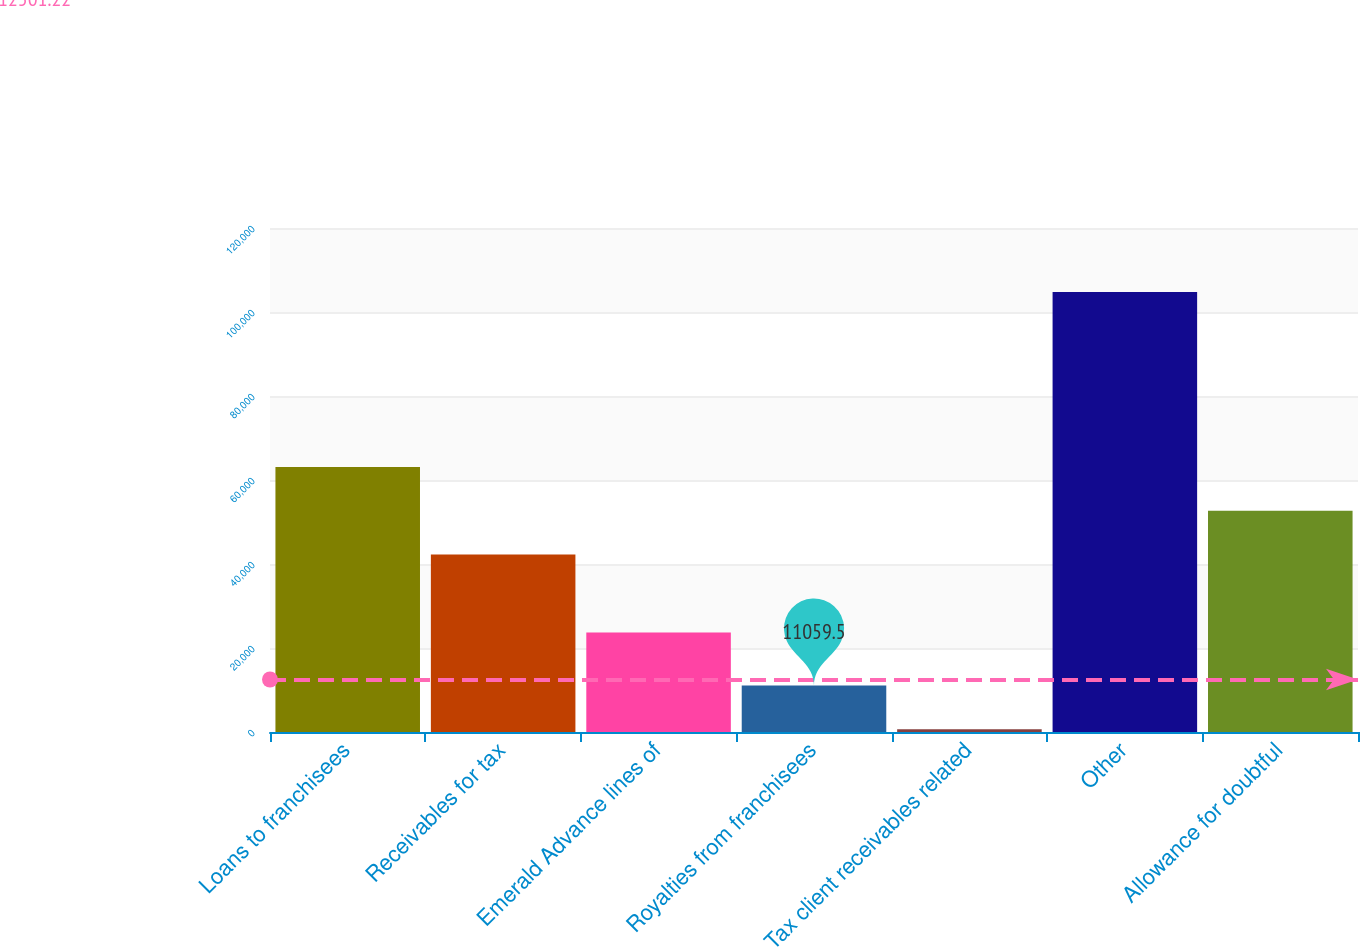Convert chart. <chart><loc_0><loc_0><loc_500><loc_500><bar_chart><fcel>Loans to franchisees<fcel>Receivables for tax<fcel>Emerald Advance lines of<fcel>Royalties from franchisees<fcel>Tax client receivables related<fcel>Other<fcel>Allowance for doubtful<nl><fcel>63109<fcel>42286<fcel>23717<fcel>11059.5<fcel>648<fcel>104763<fcel>52697.5<nl></chart> 